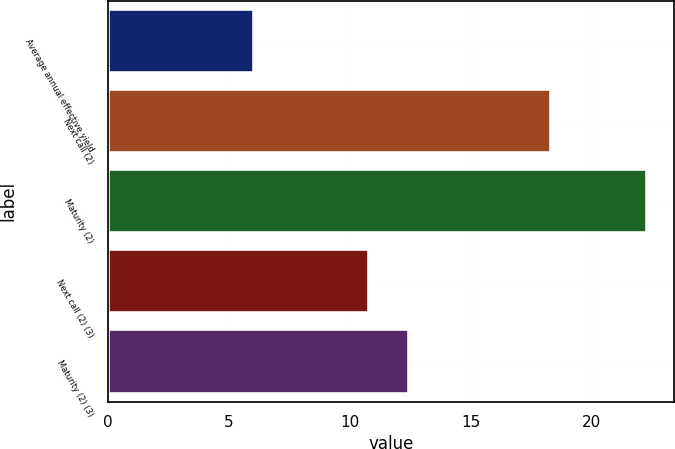Convert chart to OTSL. <chart><loc_0><loc_0><loc_500><loc_500><bar_chart><fcel>Average annual effective yield<fcel>Next call (2)<fcel>Maturity (2)<fcel>Next call (2) (3)<fcel>Maturity (2) (3)<nl><fcel>6.04<fcel>18.3<fcel>22.3<fcel>10.8<fcel>12.43<nl></chart> 